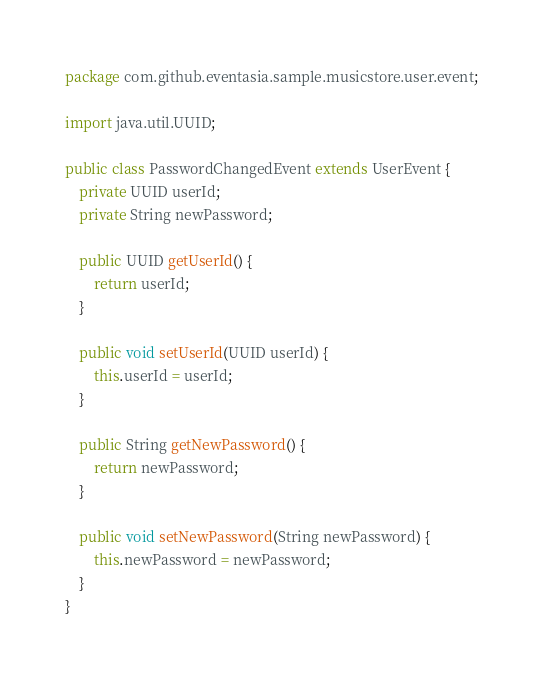Convert code to text. <code><loc_0><loc_0><loc_500><loc_500><_Java_>package com.github.eventasia.sample.musicstore.user.event;

import java.util.UUID;

public class PasswordChangedEvent extends UserEvent {
    private UUID userId;
    private String newPassword;

    public UUID getUserId() {
        return userId;
    }

    public void setUserId(UUID userId) {
        this.userId = userId;
    }

    public String getNewPassword() {
        return newPassword;
    }

    public void setNewPassword(String newPassword) {
        this.newPassword = newPassword;
    }
}
</code> 